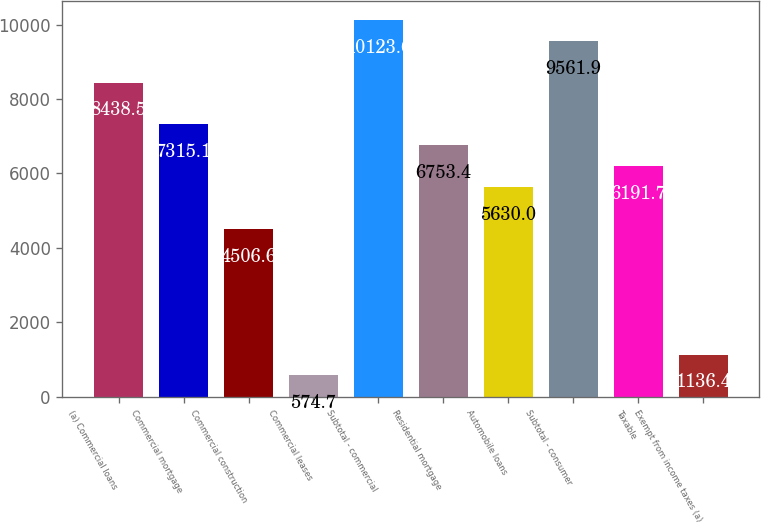Convert chart to OTSL. <chart><loc_0><loc_0><loc_500><loc_500><bar_chart><fcel>(a) Commercial loans<fcel>Commercial mortgage<fcel>Commercial construction<fcel>Commercial leases<fcel>Subtotal - commercial<fcel>Residential mortgage<fcel>Automobile loans<fcel>Subtotal - consumer<fcel>Taxable<fcel>Exempt from income taxes (a)<nl><fcel>8438.5<fcel>7315.1<fcel>4506.6<fcel>574.7<fcel>10123.6<fcel>6753.4<fcel>5630<fcel>9561.9<fcel>6191.7<fcel>1136.4<nl></chart> 